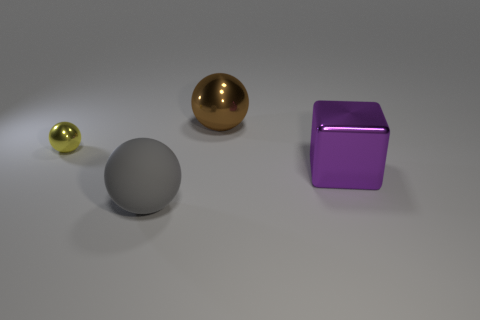How many things are either big purple rubber cylinders or large brown balls?
Provide a short and direct response. 1. Is there anything else that has the same material as the gray object?
Provide a succinct answer. No. Is there a red metallic sphere?
Your answer should be compact. No. Is the material of the sphere that is behind the small yellow shiny object the same as the big cube?
Offer a very short reply. Yes. Are there any brown metallic things of the same shape as the purple thing?
Make the answer very short. No. Are there the same number of small yellow balls to the right of the gray matte ball and small blue rubber balls?
Your answer should be compact. Yes. The big ball left of the metal sphere to the right of the matte object is made of what material?
Give a very brief answer. Rubber. The small yellow metallic thing is what shape?
Give a very brief answer. Sphere. Are there the same number of rubber balls that are on the left side of the gray object and tiny metal things that are on the left side of the tiny metallic object?
Provide a succinct answer. Yes. Is the color of the large metallic object that is behind the small yellow object the same as the metal object in front of the small yellow object?
Keep it short and to the point. No. 